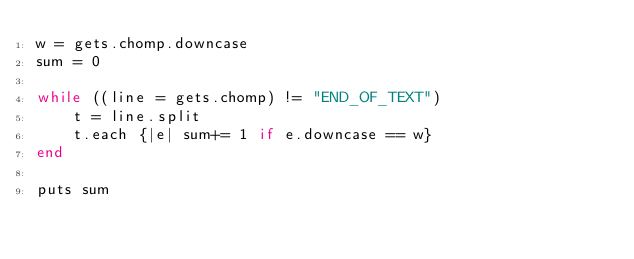Convert code to text. <code><loc_0><loc_0><loc_500><loc_500><_Ruby_>w = gets.chomp.downcase
sum = 0

while ((line = gets.chomp) != "END_OF_TEXT") 
    t = line.split
    t.each {|e| sum+= 1 if e.downcase == w}
end

puts sum


</code> 